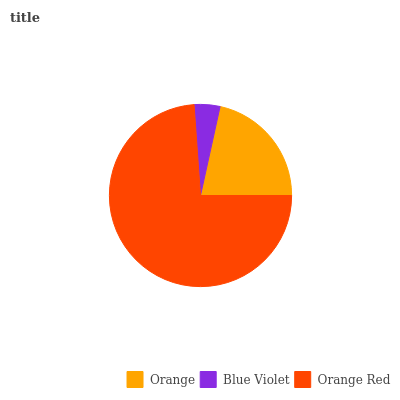Is Blue Violet the minimum?
Answer yes or no. Yes. Is Orange Red the maximum?
Answer yes or no. Yes. Is Orange Red the minimum?
Answer yes or no. No. Is Blue Violet the maximum?
Answer yes or no. No. Is Orange Red greater than Blue Violet?
Answer yes or no. Yes. Is Blue Violet less than Orange Red?
Answer yes or no. Yes. Is Blue Violet greater than Orange Red?
Answer yes or no. No. Is Orange Red less than Blue Violet?
Answer yes or no. No. Is Orange the high median?
Answer yes or no. Yes. Is Orange the low median?
Answer yes or no. Yes. Is Blue Violet the high median?
Answer yes or no. No. Is Blue Violet the low median?
Answer yes or no. No. 